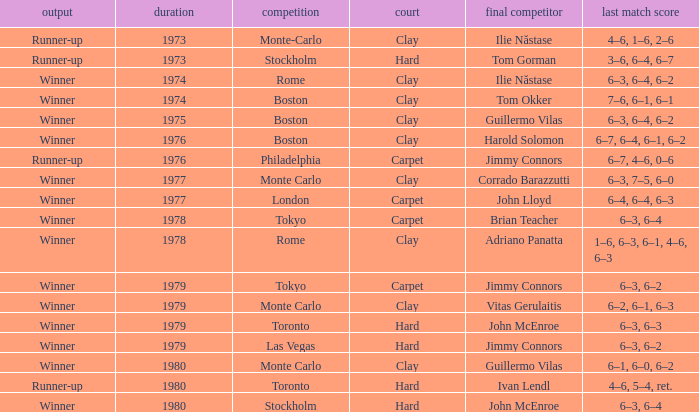Name the total number of opponent in the final for 6–2, 6–1, 6–3 1.0. Could you help me parse every detail presented in this table? {'header': ['output', 'duration', 'competition', 'court', 'final competitor', 'last match score'], 'rows': [['Runner-up', '1973', 'Monte-Carlo', 'Clay', 'Ilie Năstase', '4–6, 1–6, 2–6'], ['Runner-up', '1973', 'Stockholm', 'Hard', 'Tom Gorman', '3–6, 6–4, 6–7'], ['Winner', '1974', 'Rome', 'Clay', 'Ilie Năstase', '6–3, 6–4, 6–2'], ['Winner', '1974', 'Boston', 'Clay', 'Tom Okker', '7–6, 6–1, 6–1'], ['Winner', '1975', 'Boston', 'Clay', 'Guillermo Vilas', '6–3, 6–4, 6–2'], ['Winner', '1976', 'Boston', 'Clay', 'Harold Solomon', '6–7, 6–4, 6–1, 6–2'], ['Runner-up', '1976', 'Philadelphia', 'Carpet', 'Jimmy Connors', '6–7, 4–6, 0–6'], ['Winner', '1977', 'Monte Carlo', 'Clay', 'Corrado Barazzutti', '6–3, 7–5, 6–0'], ['Winner', '1977', 'London', 'Carpet', 'John Lloyd', '6–4, 6–4, 6–3'], ['Winner', '1978', 'Tokyo', 'Carpet', 'Brian Teacher', '6–3, 6–4'], ['Winner', '1978', 'Rome', 'Clay', 'Adriano Panatta', '1–6, 6–3, 6–1, 4–6, 6–3'], ['Winner', '1979', 'Tokyo', 'Carpet', 'Jimmy Connors', '6–3, 6–2'], ['Winner', '1979', 'Monte Carlo', 'Clay', 'Vitas Gerulaitis', '6–2, 6–1, 6–3'], ['Winner', '1979', 'Toronto', 'Hard', 'John McEnroe', '6–3, 6–3'], ['Winner', '1979', 'Las Vegas', 'Hard', 'Jimmy Connors', '6–3, 6–2'], ['Winner', '1980', 'Monte Carlo', 'Clay', 'Guillermo Vilas', '6–1, 6–0, 6–2'], ['Runner-up', '1980', 'Toronto', 'Hard', 'Ivan Lendl', '4–6, 5–4, ret.'], ['Winner', '1980', 'Stockholm', 'Hard', 'John McEnroe', '6–3, 6–4']]} 